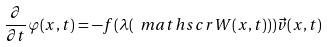<formula> <loc_0><loc_0><loc_500><loc_500>\frac { \partial } { \partial t } \varphi ( x , t ) = - f ( \lambda ( \ m a t h s c r { W } ( x , t ) ) ) \vec { v } ( x , t ) \\</formula> 